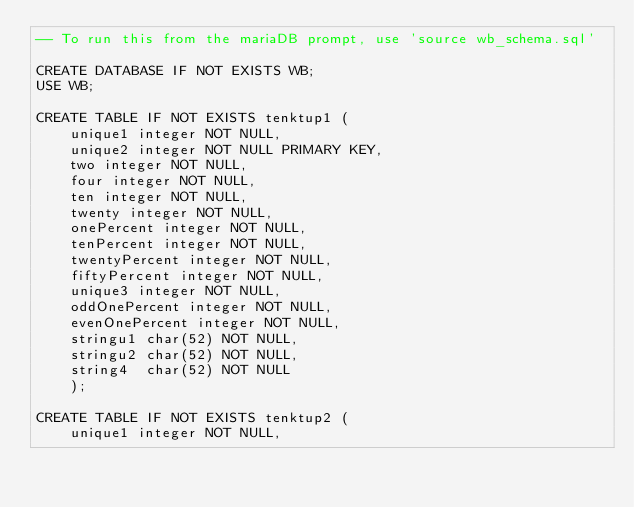Convert code to text. <code><loc_0><loc_0><loc_500><loc_500><_SQL_>-- To run this from the mariaDB prompt, use 'source wb_schema.sql'

CREATE DATABASE IF NOT EXISTS WB;
USE WB;

CREATE TABLE IF NOT EXISTS tenktup1 (
    unique1 integer NOT NULL,
    unique2 integer NOT NULL PRIMARY KEY,
    two integer NOT NULL,
    four integer NOT NULL,
    ten integer NOT NULL,
    twenty integer NOT NULL,
    onePercent integer NOT NULL,
    tenPercent integer NOT NULL,
    twentyPercent integer NOT NULL,
    fiftyPercent integer NOT NULL,
    unique3 integer NOT NULL,
    oddOnePercent integer NOT NULL,
    evenOnePercent integer NOT NULL,
    stringu1 char(52) NOT NULL,
    stringu2 char(52) NOT NULL,
    string4  char(52) NOT NULL
    );

CREATE TABLE IF NOT EXISTS tenktup2 (
    unique1 integer NOT NULL,</code> 